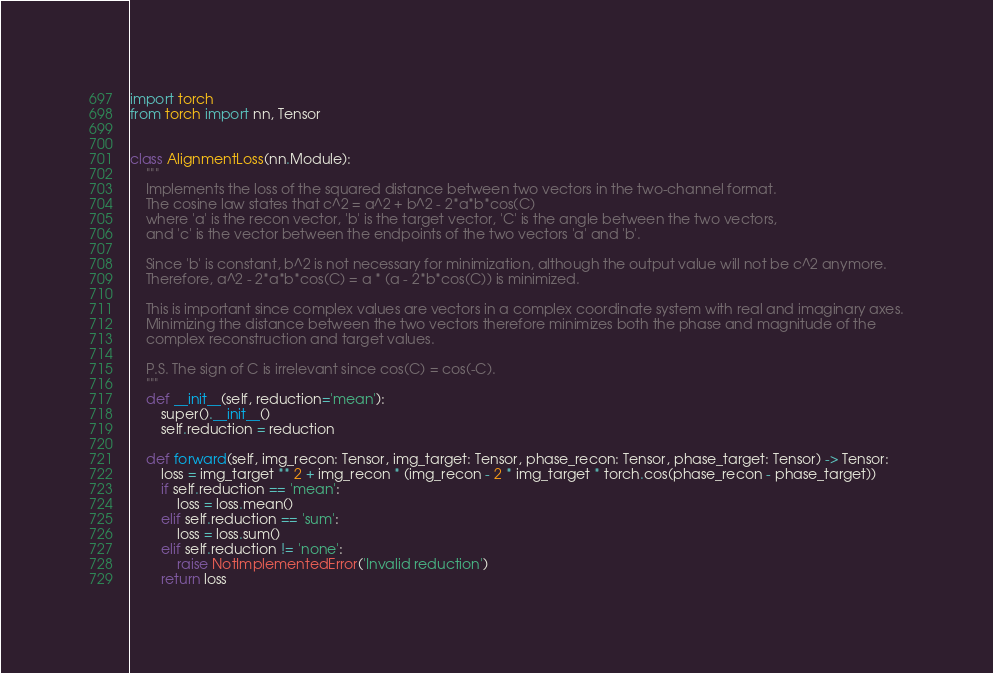Convert code to text. <code><loc_0><loc_0><loc_500><loc_500><_Python_>import torch
from torch import nn, Tensor


class AlignmentLoss(nn.Module):
    """
    Implements the loss of the squared distance between two vectors in the two-channel format.
    The cosine law states that c^2 = a^2 + b^2 - 2*a*b*cos(C)
    where 'a' is the recon vector, 'b' is the target vector, 'C' is the angle between the two vectors,
    and 'c' is the vector between the endpoints of the two vectors 'a' and 'b'.

    Since 'b' is constant, b^2 is not necessary for minimization, although the output value will not be c^2 anymore.
    Therefore, a^2 - 2*a*b*cos(C) = a * (a - 2*b*cos(C)) is minimized.

    This is important since complex values are vectors in a complex coordinate system with real and imaginary axes.
    Minimizing the distance between the two vectors therefore minimizes both the phase and magnitude of the
    complex reconstruction and target values.

    P.S. The sign of C is irrelevant since cos(C) = cos(-C).
    """
    def __init__(self, reduction='mean'):
        super().__init__()
        self.reduction = reduction

    def forward(self, img_recon: Tensor, img_target: Tensor, phase_recon: Tensor, phase_target: Tensor) -> Tensor:
        loss = img_target ** 2 + img_recon * (img_recon - 2 * img_target * torch.cos(phase_recon - phase_target))
        if self.reduction == 'mean':
            loss = loss.mean()
        elif self.reduction == 'sum':
            loss = loss.sum()
        elif self.reduction != 'none':
            raise NotImplementedError('Invalid reduction')
        return loss
</code> 